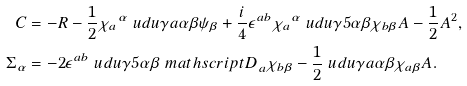Convert formula to latex. <formula><loc_0><loc_0><loc_500><loc_500>C & = - { R } - \frac { 1 } { 2 } { \chi _ { a } } ^ { \alpha } \ u d u \gamma { a } \alpha \beta \psi _ { \beta } + \frac { i } { 4 } \epsilon ^ { a b } { \chi _ { a } } ^ { \alpha } \ u d u \gamma 5 \alpha \beta \chi _ { b \beta } A - \frac { 1 } { 2 } A ^ { 2 } , \\ \Sigma _ { \alpha } & = - 2 \epsilon ^ { a b } \ u d u \gamma 5 \alpha \beta { \ m a t h s c r i p t { D } } _ { a } \chi _ { b \beta } - \frac { 1 } { 2 } \ u d u \gamma { a } \alpha \beta \chi _ { a \beta } A .</formula> 